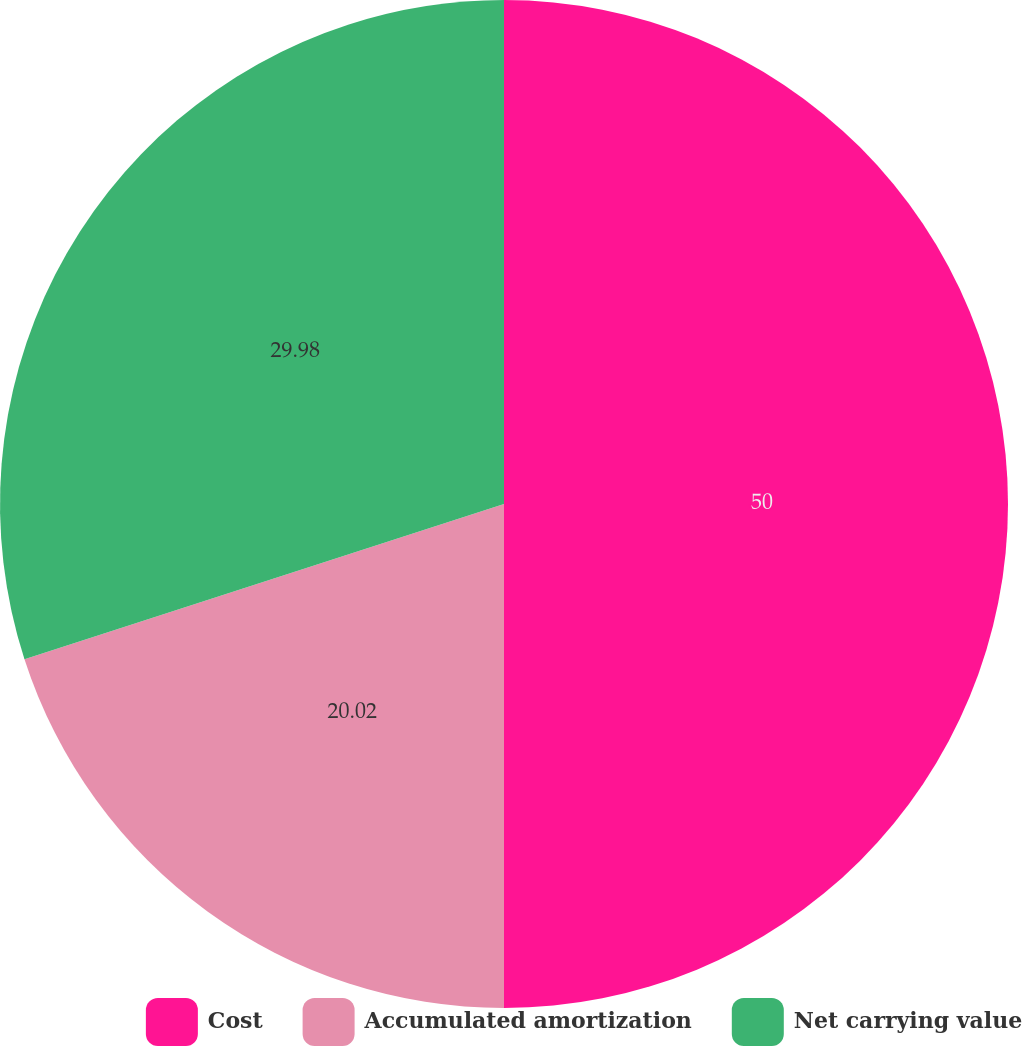<chart> <loc_0><loc_0><loc_500><loc_500><pie_chart><fcel>Cost<fcel>Accumulated amortization<fcel>Net carrying value<nl><fcel>50.0%<fcel>20.02%<fcel>29.98%<nl></chart> 